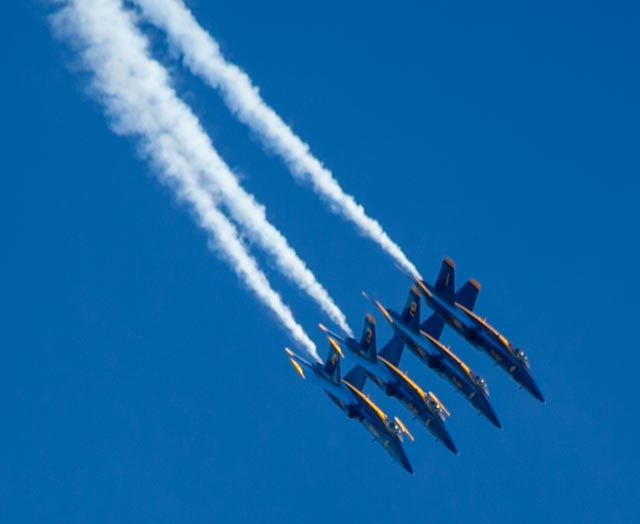Describe the objects in this image and their specific colors. I can see airplane in blue, navy, and gray tones, airplane in blue, navy, and black tones, airplane in blue, navy, and darkblue tones, and airplane in blue, navy, black, and darkblue tones in this image. 